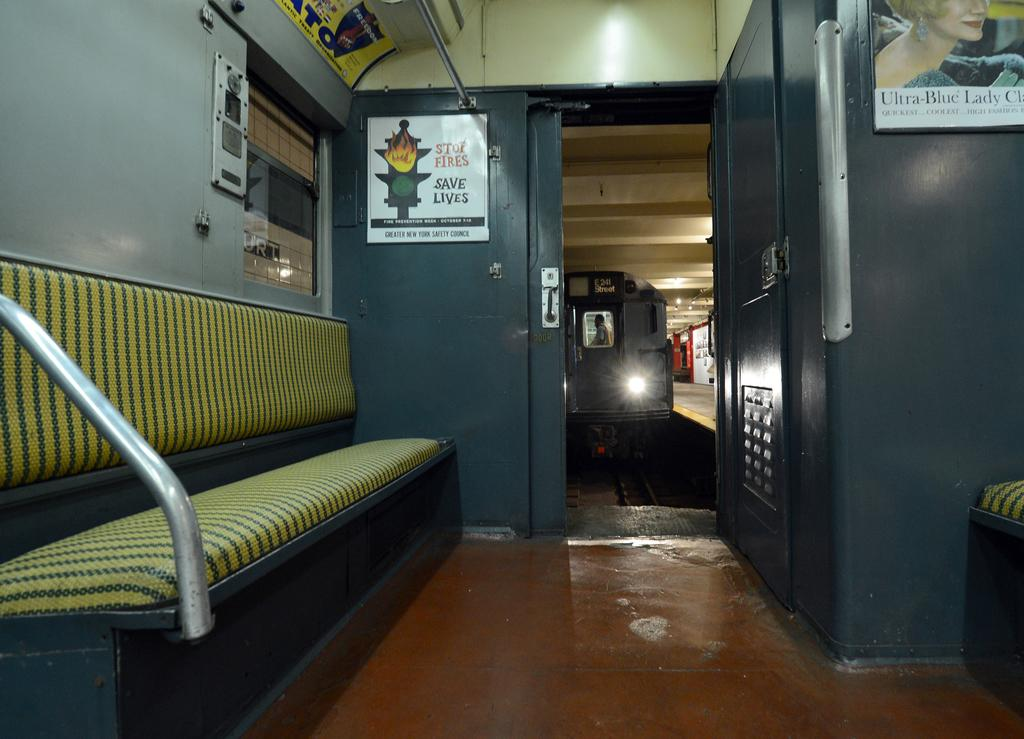Provide a one-sentence caption for the provided image. an inside of a train with a sign saying ST of Fire Saves Lives. 